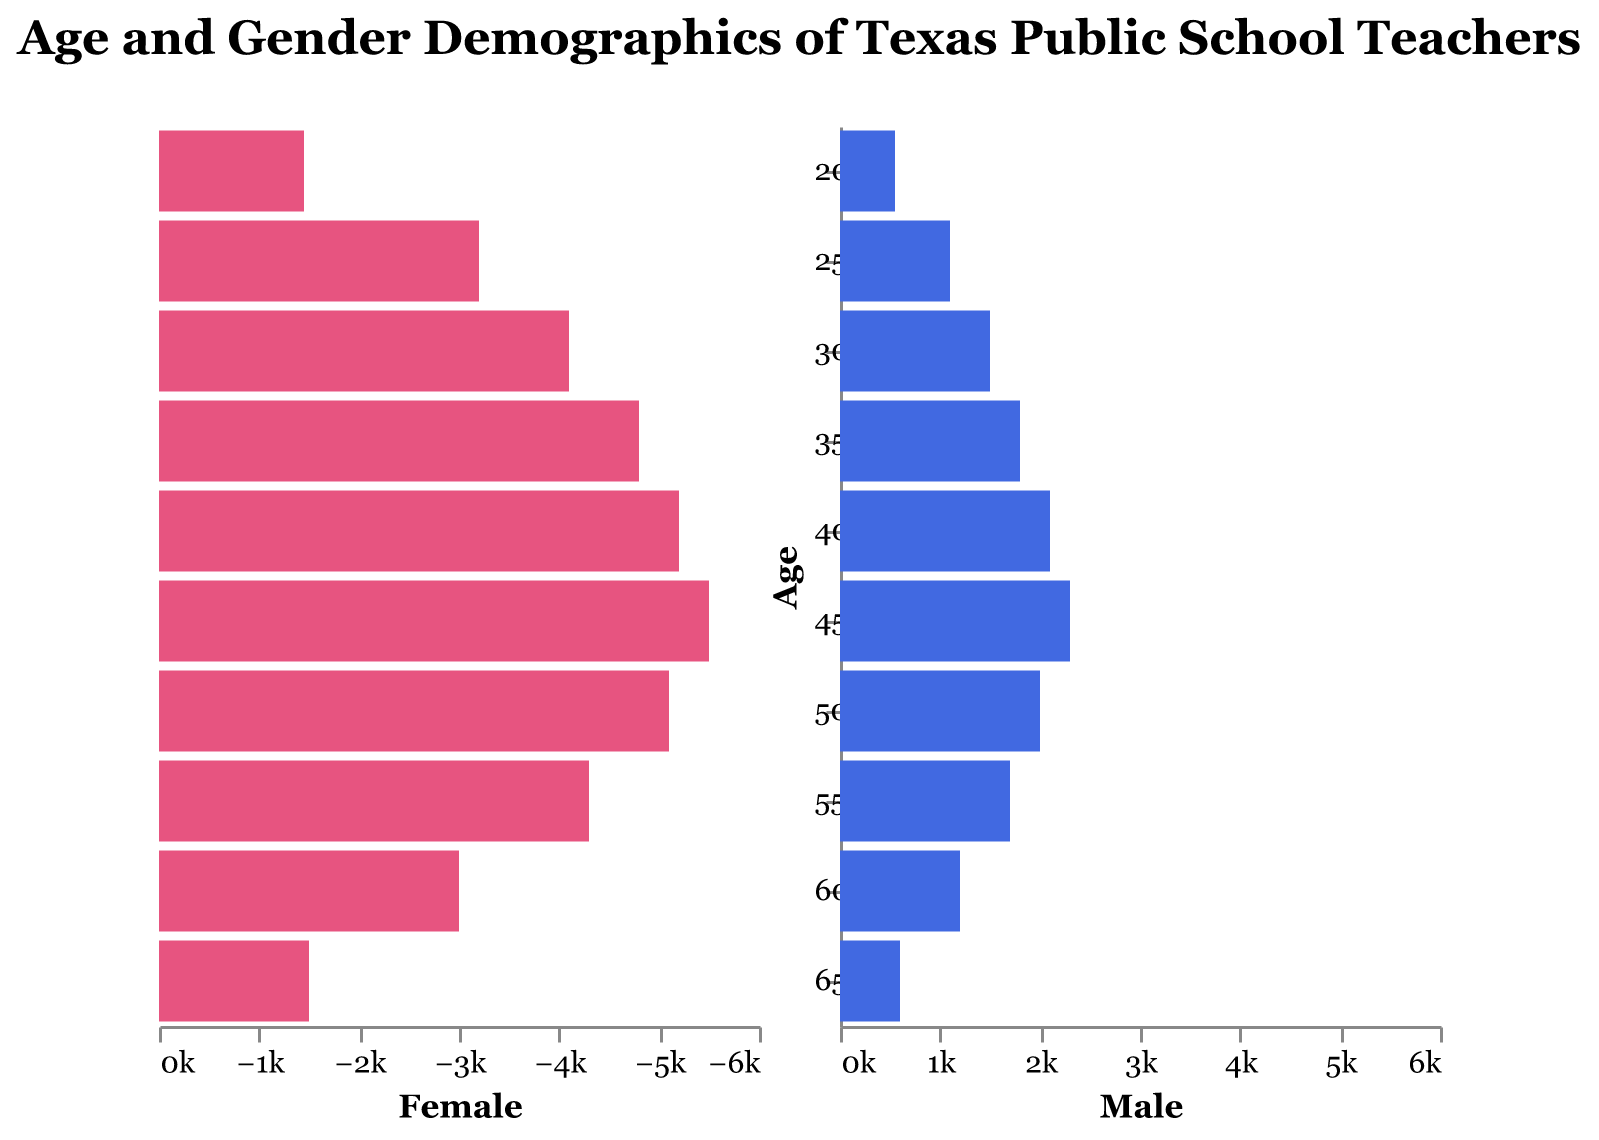What's the overall trend in the number of female teachers across age groups? To identify the trend, observe the sizes of the pink bars (female representation) across the age groups on the left side of the pyramid. The number of female teachers increases from the 20-24 age group to the 45-49 age group, then it declines in the higher age groups (50-54 onwards).
Answer: Increases to age 45-49, then decreases Which age group has the highest number of male teachers? Check the longest blue bar on the right side of the pyramid, representing male teachers. The age group 45-49 has the highest number of male teachers, with a value of 2300.
Answer: 45-49 What is the number of female teachers aged 35-39 compared to those aged 45-49? Look at the pink bars for the age groups 35-39 and 45-49. The 35-39 age group has 4800 female teachers, whereas the 45-49 age group has 5500 female teachers.
Answer: 4800 vs 5500 Which gender has more teachers aged 60-64, and by how much? Compare the bars for the 60-64 age group on both sides of the pyramid. The female bar shows 3000 while the male bar shows 1200. The difference is 3000 - 1200 = 1800.
Answer: Female, by 1800 What is the combined number of male and female teachers aged 20-24? For the 20-24 age group, sum the number of female and male teachers. Female: 1450, Male: 550. Total = 1450 + 550.
Answer: 2000 How does the number of female teachers aged 55-59 compare to those aged 25-29? Check the heights of the pink bars for these age groups. The 55-59 age group has 4300 female teachers, and the 25-29 age group has 3200 female teachers.
Answer: 4300 vs 3200 Do any age groups have an equal number of male and female teachers? Scan both sides of the pyramid to find age groups where the bars for male and female teachers are equal in length. There are no such age groups with equal numbers.
Answer: No What percentage of teachers aged 40-44 are female? First, find the total number of teachers aged 40-44 (Female: 5200, Male: 2100). Total = 5200 + 2100 = 7300. Percentage of female teachers = (5200 / 7300) * 100.
Answer: ~71.23% Compare the number of teachers aged 50-54 to those aged 30-34. Sum the number of male and female teachers for both age groups. 50-54: Female 5100 + Male 2000 = 7100, 30-34: Female 4100 + Male 1500 = 5600.
Answer: 7100 vs 5600 